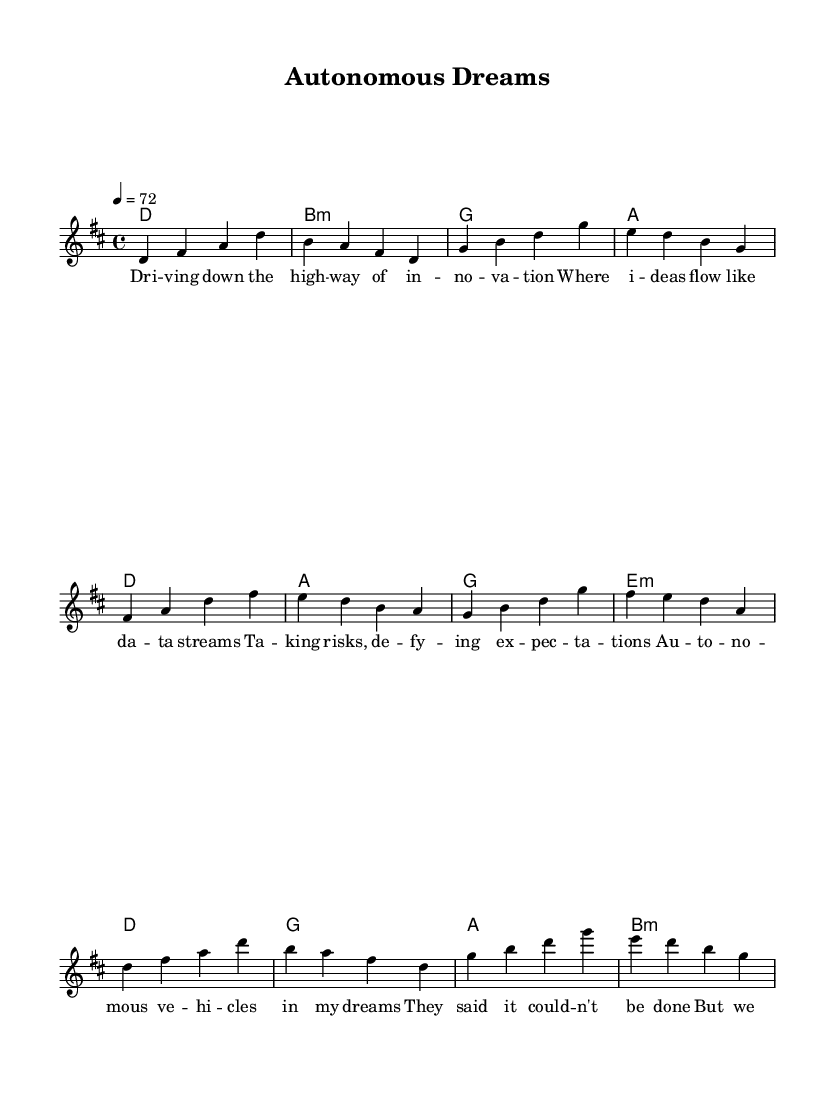What is the key signature of this music? The key signature indicated in the sheet music is D major, which has two sharps (F# and C#). This can be identified by the line that shows the key signature placed at the beginning of the staff.
Answer: D major What is the time signature? The time signature is 4/4, which is indicated at the beginning of the score. This means there are four beats in a measure and the quarter note gets one beat.
Answer: 4/4 What is the tempo marking? The tempo marking is 72, which means there are 72 beats per minute. This is defined at the start of the piece in the tempo indication, where it specifies that the quarter note (4) equals 72 beats.
Answer: 72 How many sections are there in the song? The song has three main sections: Verse, Pre-Chorus, and Chorus. Each section is clearly labeled, allowing for easy identification of the song’s structure.
Answer: Three What kind of chord progression is used in the Chorus? The chord progression used in the Chorus consists of the chords D, G, A, and B minor. This can be found in the harmonies section matched with the lyrics of the Chorus.
Answer: D, G, A, B minor What is the main theme of the lyrics? The main theme of the lyrics revolves around taking risks and believing in innovation in the context of autonomous vehicles and new ideas. This is derived from the content of the verses and the Chorus emphasizing belief in new possibilities.
Answer: Risk and innovation 